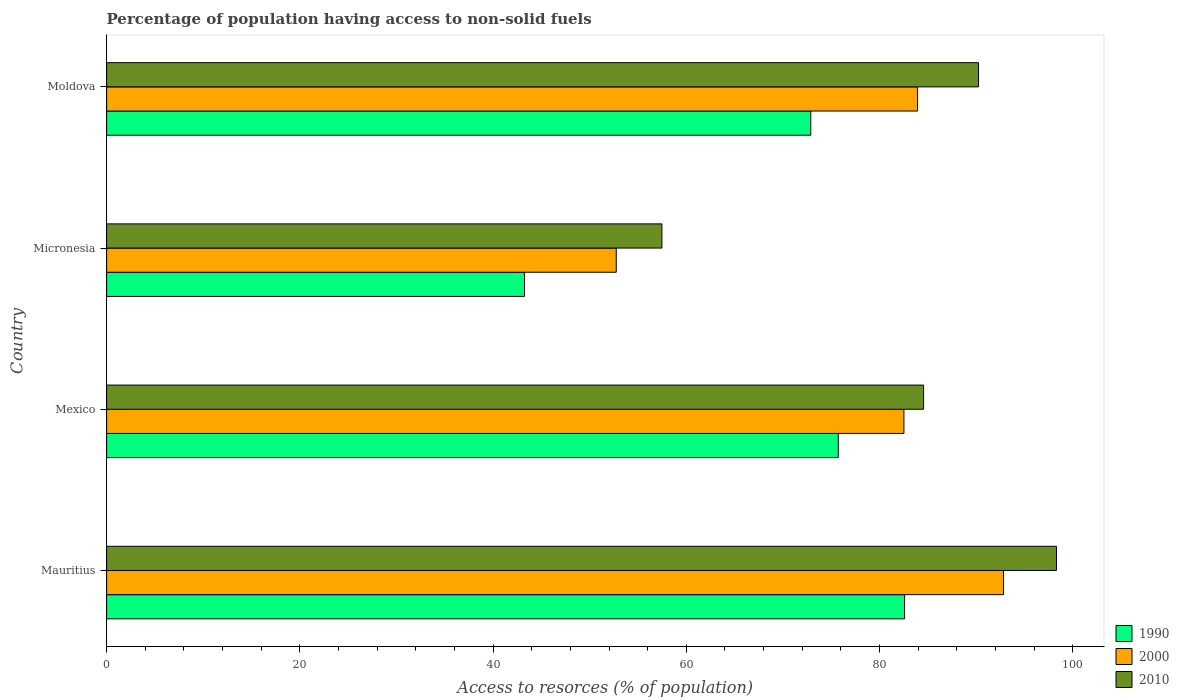Are the number of bars per tick equal to the number of legend labels?
Offer a terse response. Yes. How many bars are there on the 3rd tick from the top?
Provide a succinct answer. 3. What is the label of the 2nd group of bars from the top?
Your answer should be compact. Micronesia. What is the percentage of population having access to non-solid fuels in 2000 in Moldova?
Offer a terse response. 83.93. Across all countries, what is the maximum percentage of population having access to non-solid fuels in 1990?
Provide a succinct answer. 82.59. Across all countries, what is the minimum percentage of population having access to non-solid fuels in 2000?
Offer a very short reply. 52.75. In which country was the percentage of population having access to non-solid fuels in 2000 maximum?
Make the answer very short. Mauritius. In which country was the percentage of population having access to non-solid fuels in 2000 minimum?
Offer a terse response. Micronesia. What is the total percentage of population having access to non-solid fuels in 2010 in the graph?
Offer a terse response. 330.59. What is the difference between the percentage of population having access to non-solid fuels in 2010 in Mexico and that in Moldova?
Provide a succinct answer. -5.68. What is the difference between the percentage of population having access to non-solid fuels in 2010 in Mauritius and the percentage of population having access to non-solid fuels in 1990 in Micronesia?
Give a very brief answer. 55.06. What is the average percentage of population having access to non-solid fuels in 2000 per country?
Make the answer very short. 78.01. What is the difference between the percentage of population having access to non-solid fuels in 1990 and percentage of population having access to non-solid fuels in 2000 in Micronesia?
Offer a very short reply. -9.49. In how many countries, is the percentage of population having access to non-solid fuels in 1990 greater than 12 %?
Provide a succinct answer. 4. What is the ratio of the percentage of population having access to non-solid fuels in 1990 in Mauritius to that in Moldova?
Keep it short and to the point. 1.13. Is the difference between the percentage of population having access to non-solid fuels in 1990 in Micronesia and Moldova greater than the difference between the percentage of population having access to non-solid fuels in 2000 in Micronesia and Moldova?
Offer a terse response. Yes. What is the difference between the highest and the second highest percentage of population having access to non-solid fuels in 1990?
Ensure brevity in your answer.  6.86. What is the difference between the highest and the lowest percentage of population having access to non-solid fuels in 1990?
Make the answer very short. 39.33. What does the 3rd bar from the bottom in Micronesia represents?
Offer a terse response. 2010. Is it the case that in every country, the sum of the percentage of population having access to non-solid fuels in 2000 and percentage of population having access to non-solid fuels in 1990 is greater than the percentage of population having access to non-solid fuels in 2010?
Offer a very short reply. Yes. How many bars are there?
Offer a very short reply. 12. Are all the bars in the graph horizontal?
Offer a very short reply. Yes. How many countries are there in the graph?
Give a very brief answer. 4. What is the difference between two consecutive major ticks on the X-axis?
Ensure brevity in your answer.  20. Are the values on the major ticks of X-axis written in scientific E-notation?
Offer a very short reply. No. What is the title of the graph?
Offer a terse response. Percentage of population having access to non-solid fuels. Does "2000" appear as one of the legend labels in the graph?
Keep it short and to the point. Yes. What is the label or title of the X-axis?
Ensure brevity in your answer.  Access to resorces (% of population). What is the Access to resorces (% of population) in 1990 in Mauritius?
Offer a very short reply. 82.59. What is the Access to resorces (% of population) of 2000 in Mauritius?
Make the answer very short. 92.83. What is the Access to resorces (% of population) of 2010 in Mauritius?
Offer a terse response. 98.31. What is the Access to resorces (% of population) in 1990 in Mexico?
Ensure brevity in your answer.  75.73. What is the Access to resorces (% of population) of 2000 in Mexico?
Your answer should be compact. 82.52. What is the Access to resorces (% of population) of 2010 in Mexico?
Ensure brevity in your answer.  84.56. What is the Access to resorces (% of population) of 1990 in Micronesia?
Provide a short and direct response. 43.26. What is the Access to resorces (% of population) in 2000 in Micronesia?
Your answer should be very brief. 52.75. What is the Access to resorces (% of population) of 2010 in Micronesia?
Your response must be concise. 57.48. What is the Access to resorces (% of population) in 1990 in Moldova?
Your answer should be very brief. 72.88. What is the Access to resorces (% of population) in 2000 in Moldova?
Give a very brief answer. 83.93. What is the Access to resorces (% of population) of 2010 in Moldova?
Your answer should be very brief. 90.24. Across all countries, what is the maximum Access to resorces (% of population) in 1990?
Ensure brevity in your answer.  82.59. Across all countries, what is the maximum Access to resorces (% of population) of 2000?
Provide a short and direct response. 92.83. Across all countries, what is the maximum Access to resorces (% of population) of 2010?
Your answer should be very brief. 98.31. Across all countries, what is the minimum Access to resorces (% of population) of 1990?
Offer a terse response. 43.26. Across all countries, what is the minimum Access to resorces (% of population) in 2000?
Keep it short and to the point. 52.75. Across all countries, what is the minimum Access to resorces (% of population) of 2010?
Provide a short and direct response. 57.48. What is the total Access to resorces (% of population) in 1990 in the graph?
Keep it short and to the point. 274.45. What is the total Access to resorces (% of population) in 2000 in the graph?
Provide a short and direct response. 312.03. What is the total Access to resorces (% of population) of 2010 in the graph?
Your response must be concise. 330.59. What is the difference between the Access to resorces (% of population) of 1990 in Mauritius and that in Mexico?
Provide a short and direct response. 6.86. What is the difference between the Access to resorces (% of population) in 2000 in Mauritius and that in Mexico?
Offer a terse response. 10.31. What is the difference between the Access to resorces (% of population) of 2010 in Mauritius and that in Mexico?
Your answer should be very brief. 13.75. What is the difference between the Access to resorces (% of population) of 1990 in Mauritius and that in Micronesia?
Offer a very short reply. 39.33. What is the difference between the Access to resorces (% of population) of 2000 in Mauritius and that in Micronesia?
Your answer should be very brief. 40.08. What is the difference between the Access to resorces (% of population) in 2010 in Mauritius and that in Micronesia?
Offer a very short reply. 40.84. What is the difference between the Access to resorces (% of population) in 1990 in Mauritius and that in Moldova?
Your answer should be compact. 9.71. What is the difference between the Access to resorces (% of population) in 2000 in Mauritius and that in Moldova?
Ensure brevity in your answer.  8.89. What is the difference between the Access to resorces (% of population) of 2010 in Mauritius and that in Moldova?
Give a very brief answer. 8.07. What is the difference between the Access to resorces (% of population) of 1990 in Mexico and that in Micronesia?
Ensure brevity in your answer.  32.47. What is the difference between the Access to resorces (% of population) of 2000 in Mexico and that in Micronesia?
Provide a short and direct response. 29.77. What is the difference between the Access to resorces (% of population) in 2010 in Mexico and that in Micronesia?
Offer a terse response. 27.08. What is the difference between the Access to resorces (% of population) of 1990 in Mexico and that in Moldova?
Your answer should be compact. 2.85. What is the difference between the Access to resorces (% of population) in 2000 in Mexico and that in Moldova?
Give a very brief answer. -1.41. What is the difference between the Access to resorces (% of population) in 2010 in Mexico and that in Moldova?
Make the answer very short. -5.68. What is the difference between the Access to resorces (% of population) in 1990 in Micronesia and that in Moldova?
Offer a terse response. -29.62. What is the difference between the Access to resorces (% of population) in 2000 in Micronesia and that in Moldova?
Keep it short and to the point. -31.19. What is the difference between the Access to resorces (% of population) in 2010 in Micronesia and that in Moldova?
Your answer should be very brief. -32.77. What is the difference between the Access to resorces (% of population) in 1990 in Mauritius and the Access to resorces (% of population) in 2000 in Mexico?
Your answer should be compact. 0.07. What is the difference between the Access to resorces (% of population) of 1990 in Mauritius and the Access to resorces (% of population) of 2010 in Mexico?
Give a very brief answer. -1.97. What is the difference between the Access to resorces (% of population) of 2000 in Mauritius and the Access to resorces (% of population) of 2010 in Mexico?
Your answer should be compact. 8.27. What is the difference between the Access to resorces (% of population) of 1990 in Mauritius and the Access to resorces (% of population) of 2000 in Micronesia?
Your answer should be very brief. 29.84. What is the difference between the Access to resorces (% of population) in 1990 in Mauritius and the Access to resorces (% of population) in 2010 in Micronesia?
Ensure brevity in your answer.  25.11. What is the difference between the Access to resorces (% of population) of 2000 in Mauritius and the Access to resorces (% of population) of 2010 in Micronesia?
Your answer should be compact. 35.35. What is the difference between the Access to resorces (% of population) in 1990 in Mauritius and the Access to resorces (% of population) in 2000 in Moldova?
Keep it short and to the point. -1.35. What is the difference between the Access to resorces (% of population) in 1990 in Mauritius and the Access to resorces (% of population) in 2010 in Moldova?
Offer a very short reply. -7.66. What is the difference between the Access to resorces (% of population) of 2000 in Mauritius and the Access to resorces (% of population) of 2010 in Moldova?
Provide a short and direct response. 2.59. What is the difference between the Access to resorces (% of population) of 1990 in Mexico and the Access to resorces (% of population) of 2000 in Micronesia?
Offer a terse response. 22.98. What is the difference between the Access to resorces (% of population) in 1990 in Mexico and the Access to resorces (% of population) in 2010 in Micronesia?
Offer a terse response. 18.25. What is the difference between the Access to resorces (% of population) in 2000 in Mexico and the Access to resorces (% of population) in 2010 in Micronesia?
Offer a very short reply. 25.05. What is the difference between the Access to resorces (% of population) of 1990 in Mexico and the Access to resorces (% of population) of 2000 in Moldova?
Provide a succinct answer. -8.21. What is the difference between the Access to resorces (% of population) of 1990 in Mexico and the Access to resorces (% of population) of 2010 in Moldova?
Your answer should be very brief. -14.51. What is the difference between the Access to resorces (% of population) of 2000 in Mexico and the Access to resorces (% of population) of 2010 in Moldova?
Offer a very short reply. -7.72. What is the difference between the Access to resorces (% of population) in 1990 in Micronesia and the Access to resorces (% of population) in 2000 in Moldova?
Provide a short and direct response. -40.68. What is the difference between the Access to resorces (% of population) in 1990 in Micronesia and the Access to resorces (% of population) in 2010 in Moldova?
Offer a terse response. -46.99. What is the difference between the Access to resorces (% of population) in 2000 in Micronesia and the Access to resorces (% of population) in 2010 in Moldova?
Your answer should be very brief. -37.5. What is the average Access to resorces (% of population) in 1990 per country?
Offer a very short reply. 68.61. What is the average Access to resorces (% of population) of 2000 per country?
Ensure brevity in your answer.  78.01. What is the average Access to resorces (% of population) of 2010 per country?
Ensure brevity in your answer.  82.65. What is the difference between the Access to resorces (% of population) of 1990 and Access to resorces (% of population) of 2000 in Mauritius?
Provide a succinct answer. -10.24. What is the difference between the Access to resorces (% of population) of 1990 and Access to resorces (% of population) of 2010 in Mauritius?
Your response must be concise. -15.73. What is the difference between the Access to resorces (% of population) of 2000 and Access to resorces (% of population) of 2010 in Mauritius?
Provide a short and direct response. -5.48. What is the difference between the Access to resorces (% of population) in 1990 and Access to resorces (% of population) in 2000 in Mexico?
Ensure brevity in your answer.  -6.79. What is the difference between the Access to resorces (% of population) of 1990 and Access to resorces (% of population) of 2010 in Mexico?
Keep it short and to the point. -8.83. What is the difference between the Access to resorces (% of population) in 2000 and Access to resorces (% of population) in 2010 in Mexico?
Offer a terse response. -2.04. What is the difference between the Access to resorces (% of population) in 1990 and Access to resorces (% of population) in 2000 in Micronesia?
Provide a succinct answer. -9.49. What is the difference between the Access to resorces (% of population) of 1990 and Access to resorces (% of population) of 2010 in Micronesia?
Your response must be concise. -14.22. What is the difference between the Access to resorces (% of population) in 2000 and Access to resorces (% of population) in 2010 in Micronesia?
Your answer should be compact. -4.73. What is the difference between the Access to resorces (% of population) in 1990 and Access to resorces (% of population) in 2000 in Moldova?
Keep it short and to the point. -11.05. What is the difference between the Access to resorces (% of population) of 1990 and Access to resorces (% of population) of 2010 in Moldova?
Your answer should be very brief. -17.36. What is the difference between the Access to resorces (% of population) in 2000 and Access to resorces (% of population) in 2010 in Moldova?
Give a very brief answer. -6.31. What is the ratio of the Access to resorces (% of population) in 1990 in Mauritius to that in Mexico?
Your answer should be very brief. 1.09. What is the ratio of the Access to resorces (% of population) in 2000 in Mauritius to that in Mexico?
Offer a very short reply. 1.12. What is the ratio of the Access to resorces (% of population) in 2010 in Mauritius to that in Mexico?
Give a very brief answer. 1.16. What is the ratio of the Access to resorces (% of population) of 1990 in Mauritius to that in Micronesia?
Provide a short and direct response. 1.91. What is the ratio of the Access to resorces (% of population) of 2000 in Mauritius to that in Micronesia?
Your response must be concise. 1.76. What is the ratio of the Access to resorces (% of population) of 2010 in Mauritius to that in Micronesia?
Offer a very short reply. 1.71. What is the ratio of the Access to resorces (% of population) of 1990 in Mauritius to that in Moldova?
Ensure brevity in your answer.  1.13. What is the ratio of the Access to resorces (% of population) of 2000 in Mauritius to that in Moldova?
Your response must be concise. 1.11. What is the ratio of the Access to resorces (% of population) of 2010 in Mauritius to that in Moldova?
Your answer should be compact. 1.09. What is the ratio of the Access to resorces (% of population) of 1990 in Mexico to that in Micronesia?
Provide a succinct answer. 1.75. What is the ratio of the Access to resorces (% of population) in 2000 in Mexico to that in Micronesia?
Provide a short and direct response. 1.56. What is the ratio of the Access to resorces (% of population) in 2010 in Mexico to that in Micronesia?
Ensure brevity in your answer.  1.47. What is the ratio of the Access to resorces (% of population) in 1990 in Mexico to that in Moldova?
Offer a very short reply. 1.04. What is the ratio of the Access to resorces (% of population) in 2000 in Mexico to that in Moldova?
Your response must be concise. 0.98. What is the ratio of the Access to resorces (% of population) in 2010 in Mexico to that in Moldova?
Ensure brevity in your answer.  0.94. What is the ratio of the Access to resorces (% of population) in 1990 in Micronesia to that in Moldova?
Provide a succinct answer. 0.59. What is the ratio of the Access to resorces (% of population) of 2000 in Micronesia to that in Moldova?
Offer a terse response. 0.63. What is the ratio of the Access to resorces (% of population) in 2010 in Micronesia to that in Moldova?
Your answer should be very brief. 0.64. What is the difference between the highest and the second highest Access to resorces (% of population) in 1990?
Your answer should be very brief. 6.86. What is the difference between the highest and the second highest Access to resorces (% of population) in 2000?
Your answer should be compact. 8.89. What is the difference between the highest and the second highest Access to resorces (% of population) of 2010?
Your answer should be compact. 8.07. What is the difference between the highest and the lowest Access to resorces (% of population) in 1990?
Your answer should be compact. 39.33. What is the difference between the highest and the lowest Access to resorces (% of population) of 2000?
Give a very brief answer. 40.08. What is the difference between the highest and the lowest Access to resorces (% of population) of 2010?
Give a very brief answer. 40.84. 